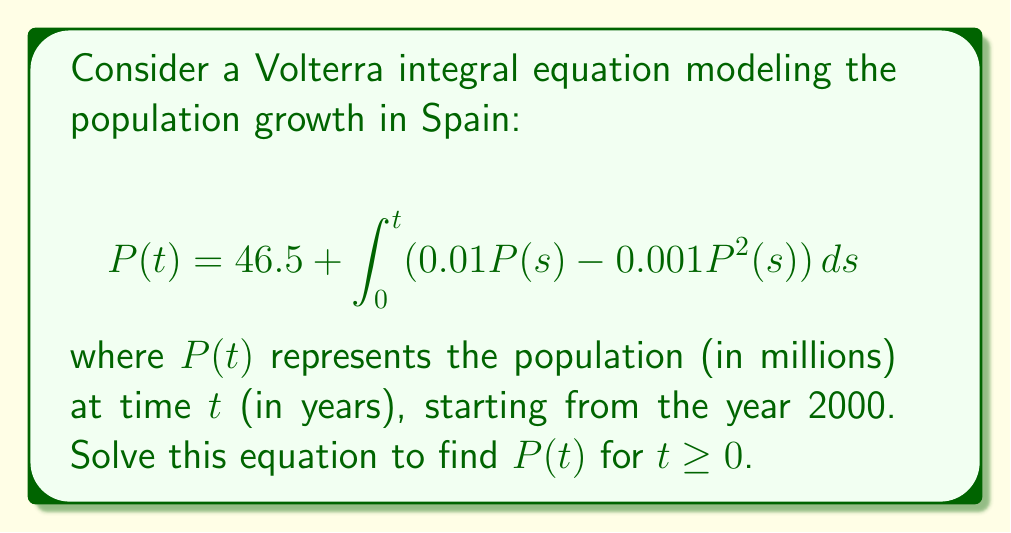Can you answer this question? Let's solve this Volterra integral equation step by step:

1) First, we recognize this as a nonlinear Volterra integral equation of the second kind.

2) To solve it, we can differentiate both sides with respect to $t$:

   $$\frac{dP}{dt} = 0.01P(t) - 0.001P^2(t)$$

3) This is now a separable differential equation. We can rewrite it as:

   $$\frac{dP}{0.01P - 0.001P^2} = dt$$

4) Integrate both sides:

   $$\int \frac{dP}{0.01P - 0.001P^2} = \int dt$$

5) The left side can be integrated using partial fractions:

   $$\int \frac{dP}{0.01P - 0.001P^2} = -100 \int \frac{dP}{P(10-P)} = -100 \left(\frac{\ln|P|}{10} - \frac{\ln|10-P|}{10}\right) + C$$

6) After integration, we have:

   $$-10\ln|P| + 10\ln|10-P| = t + C$$

7) Apply the initial condition: At $t=0$, $P(0) = 46.5$. This gives:

   $$-10\ln|46.5| + 10\ln|10-46.5| = C$$

8) Subtract this from the general solution:

   $$-10\ln|P| + 10\ln|10-P| + 10\ln|46.5| - 10\ln|-36.5| = t$$

9) Simplify and solve for $P$:

   $$\ln\left|\frac{P(10-P)}{46.5(-36.5)}\right| = -\frac{t}{10}$$

   $$\frac{P(10-P)}{-1697.25} = e^{-\frac{t}{10}}$$

   $$P(10-P) = -1697.25e^{-\frac{t}{10}}$$

   $$P^2 - 10P - 1697.25e^{-\frac{t}{10}} = 0$$

10) Solve this quadratic equation:

    $$P(t) = 5 + \sqrt{25 + 1697.25e^{-\frac{t}{10}}}$$

This is the solution to the Volterra integral equation.
Answer: $P(t) = 5 + \sqrt{25 + 1697.25e^{-\frac{t}{10}}}$ 